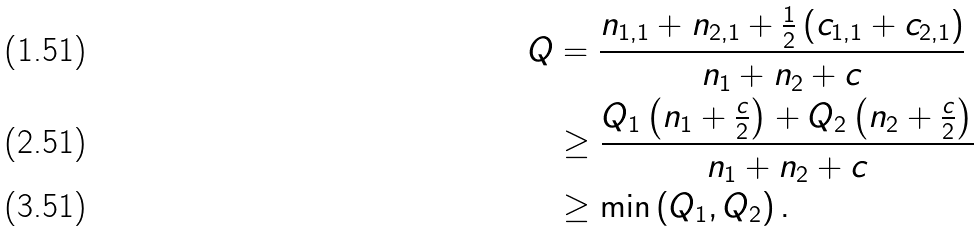Convert formula to latex. <formula><loc_0><loc_0><loc_500><loc_500>Q & = \frac { n _ { 1 , 1 } + n _ { 2 , 1 } + \frac { 1 } { 2 } \left ( c _ { 1 , 1 } + c _ { 2 , 1 } \right ) } { n _ { 1 } + n _ { 2 } + c } \\ & \geq \frac { Q _ { 1 } \left ( n _ { 1 } + \frac { c } { 2 } \right ) + Q _ { 2 } \left ( n _ { 2 } + \frac { c } { 2 } \right ) } { n _ { 1 } + n _ { 2 } + c } \\ & \geq \min \left ( Q _ { 1 } , Q _ { 2 } \right ) .</formula> 